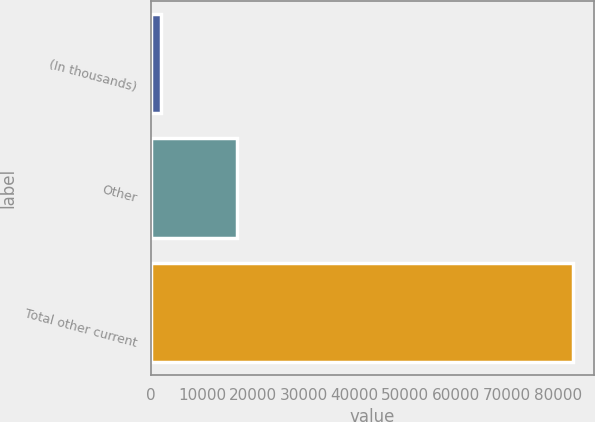Convert chart. <chart><loc_0><loc_0><loc_500><loc_500><bar_chart><fcel>(In thousands)<fcel>Other<fcel>Total other current<nl><fcel>2004<fcel>16803<fcel>82944<nl></chart> 